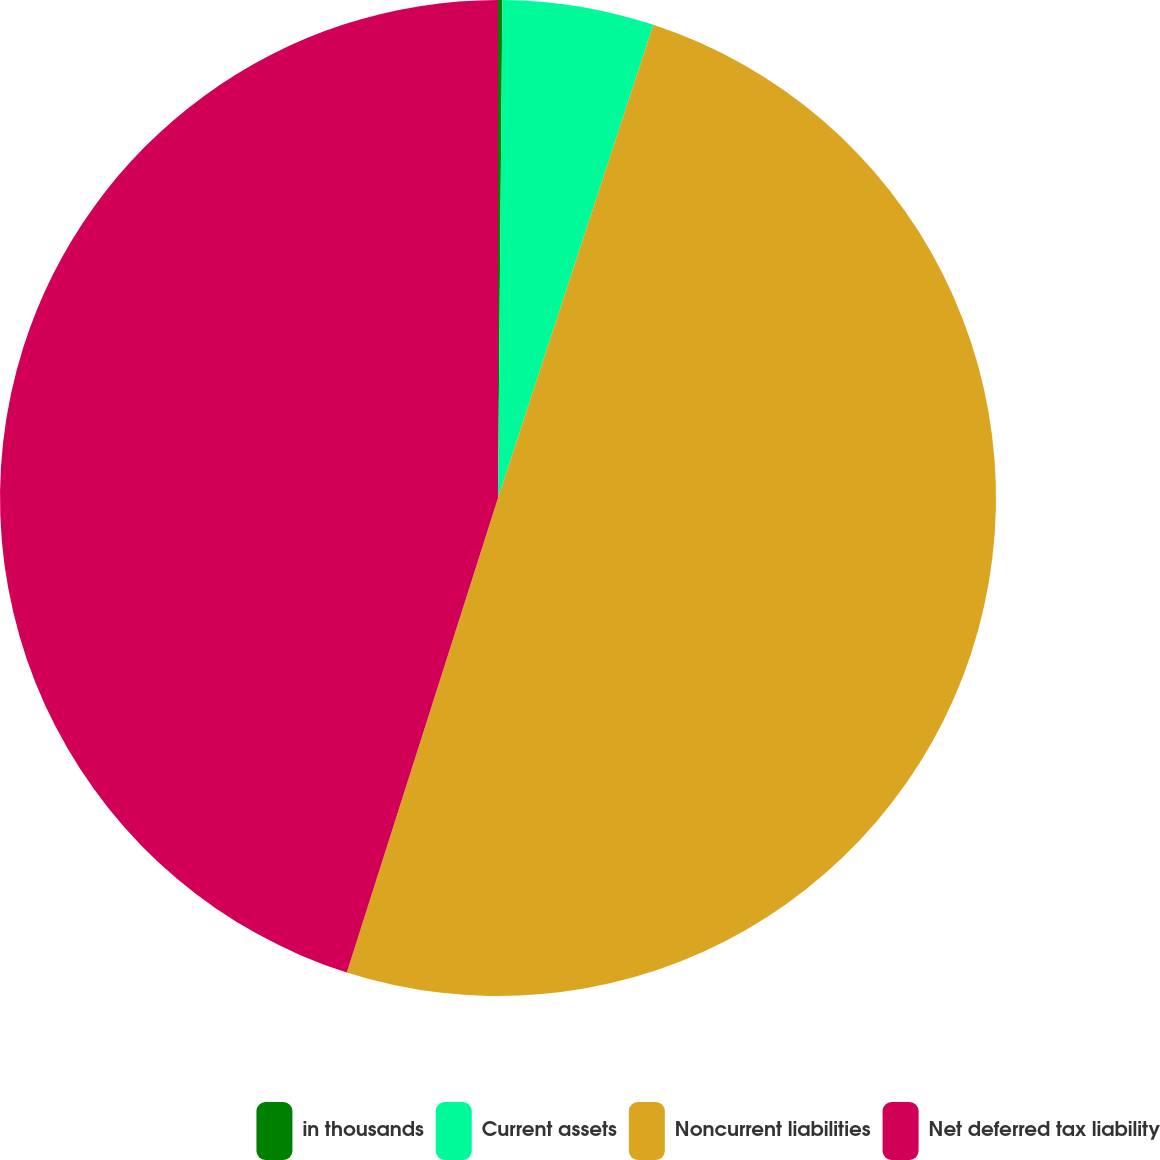Convert chart. <chart><loc_0><loc_0><loc_500><loc_500><pie_chart><fcel>in thousands<fcel>Current assets<fcel>Noncurrent liabilities<fcel>Net deferred tax liability<nl><fcel>0.14%<fcel>4.91%<fcel>49.86%<fcel>45.09%<nl></chart> 